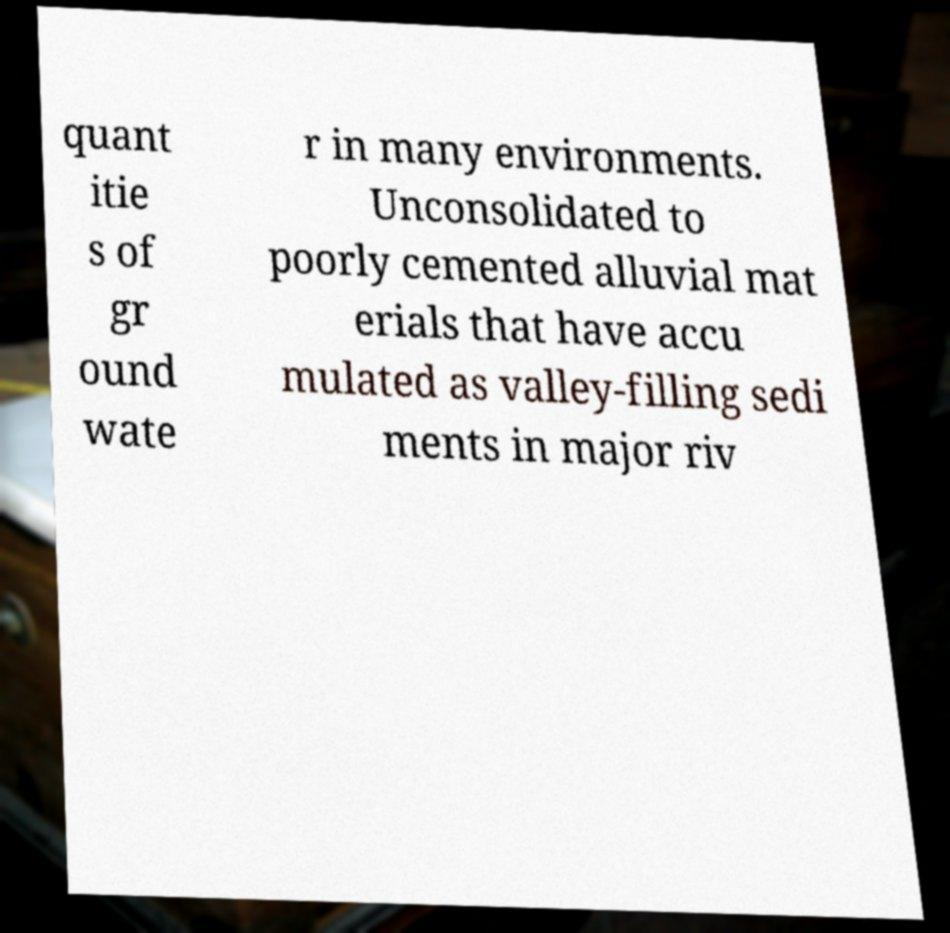Please read and relay the text visible in this image. What does it say? quant itie s of gr ound wate r in many environments. Unconsolidated to poorly cemented alluvial mat erials that have accu mulated as valley-filling sedi ments in major riv 